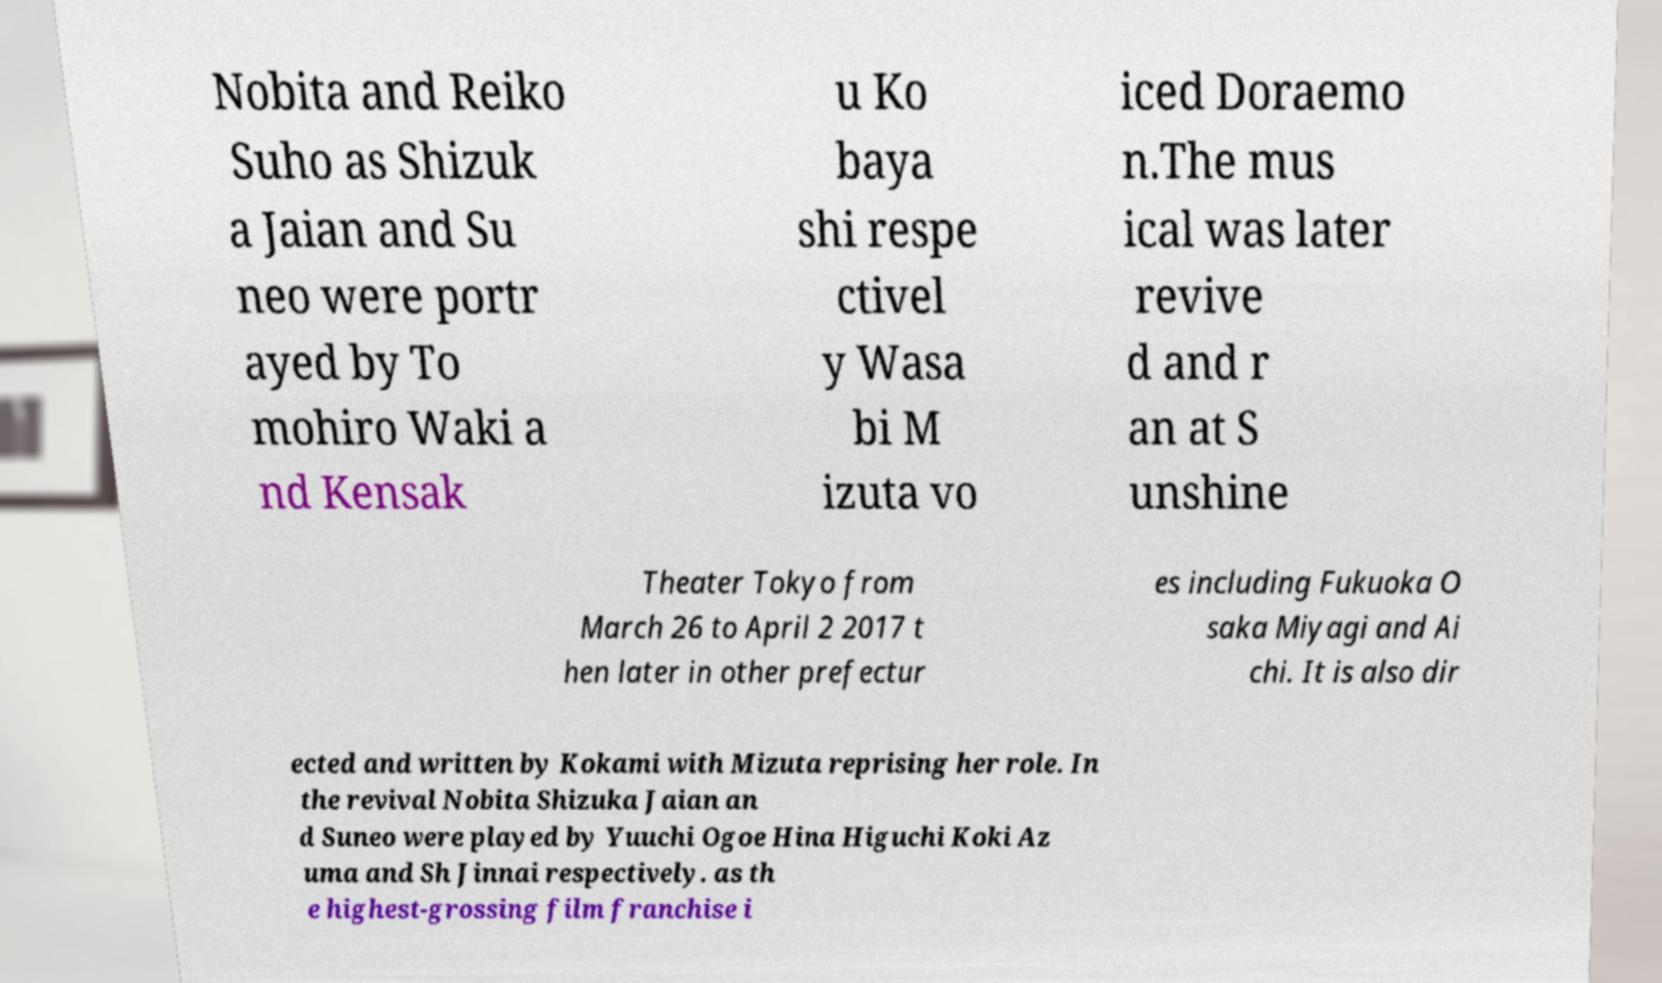I need the written content from this picture converted into text. Can you do that? Nobita and Reiko Suho as Shizuk a Jaian and Su neo were portr ayed by To mohiro Waki a nd Kensak u Ko baya shi respe ctivel y Wasa bi M izuta vo iced Doraemo n.The mus ical was later revive d and r an at S unshine Theater Tokyo from March 26 to April 2 2017 t hen later in other prefectur es including Fukuoka O saka Miyagi and Ai chi. It is also dir ected and written by Kokami with Mizuta reprising her role. In the revival Nobita Shizuka Jaian an d Suneo were played by Yuuchi Ogoe Hina Higuchi Koki Az uma and Sh Jinnai respectively. as th e highest-grossing film franchise i 